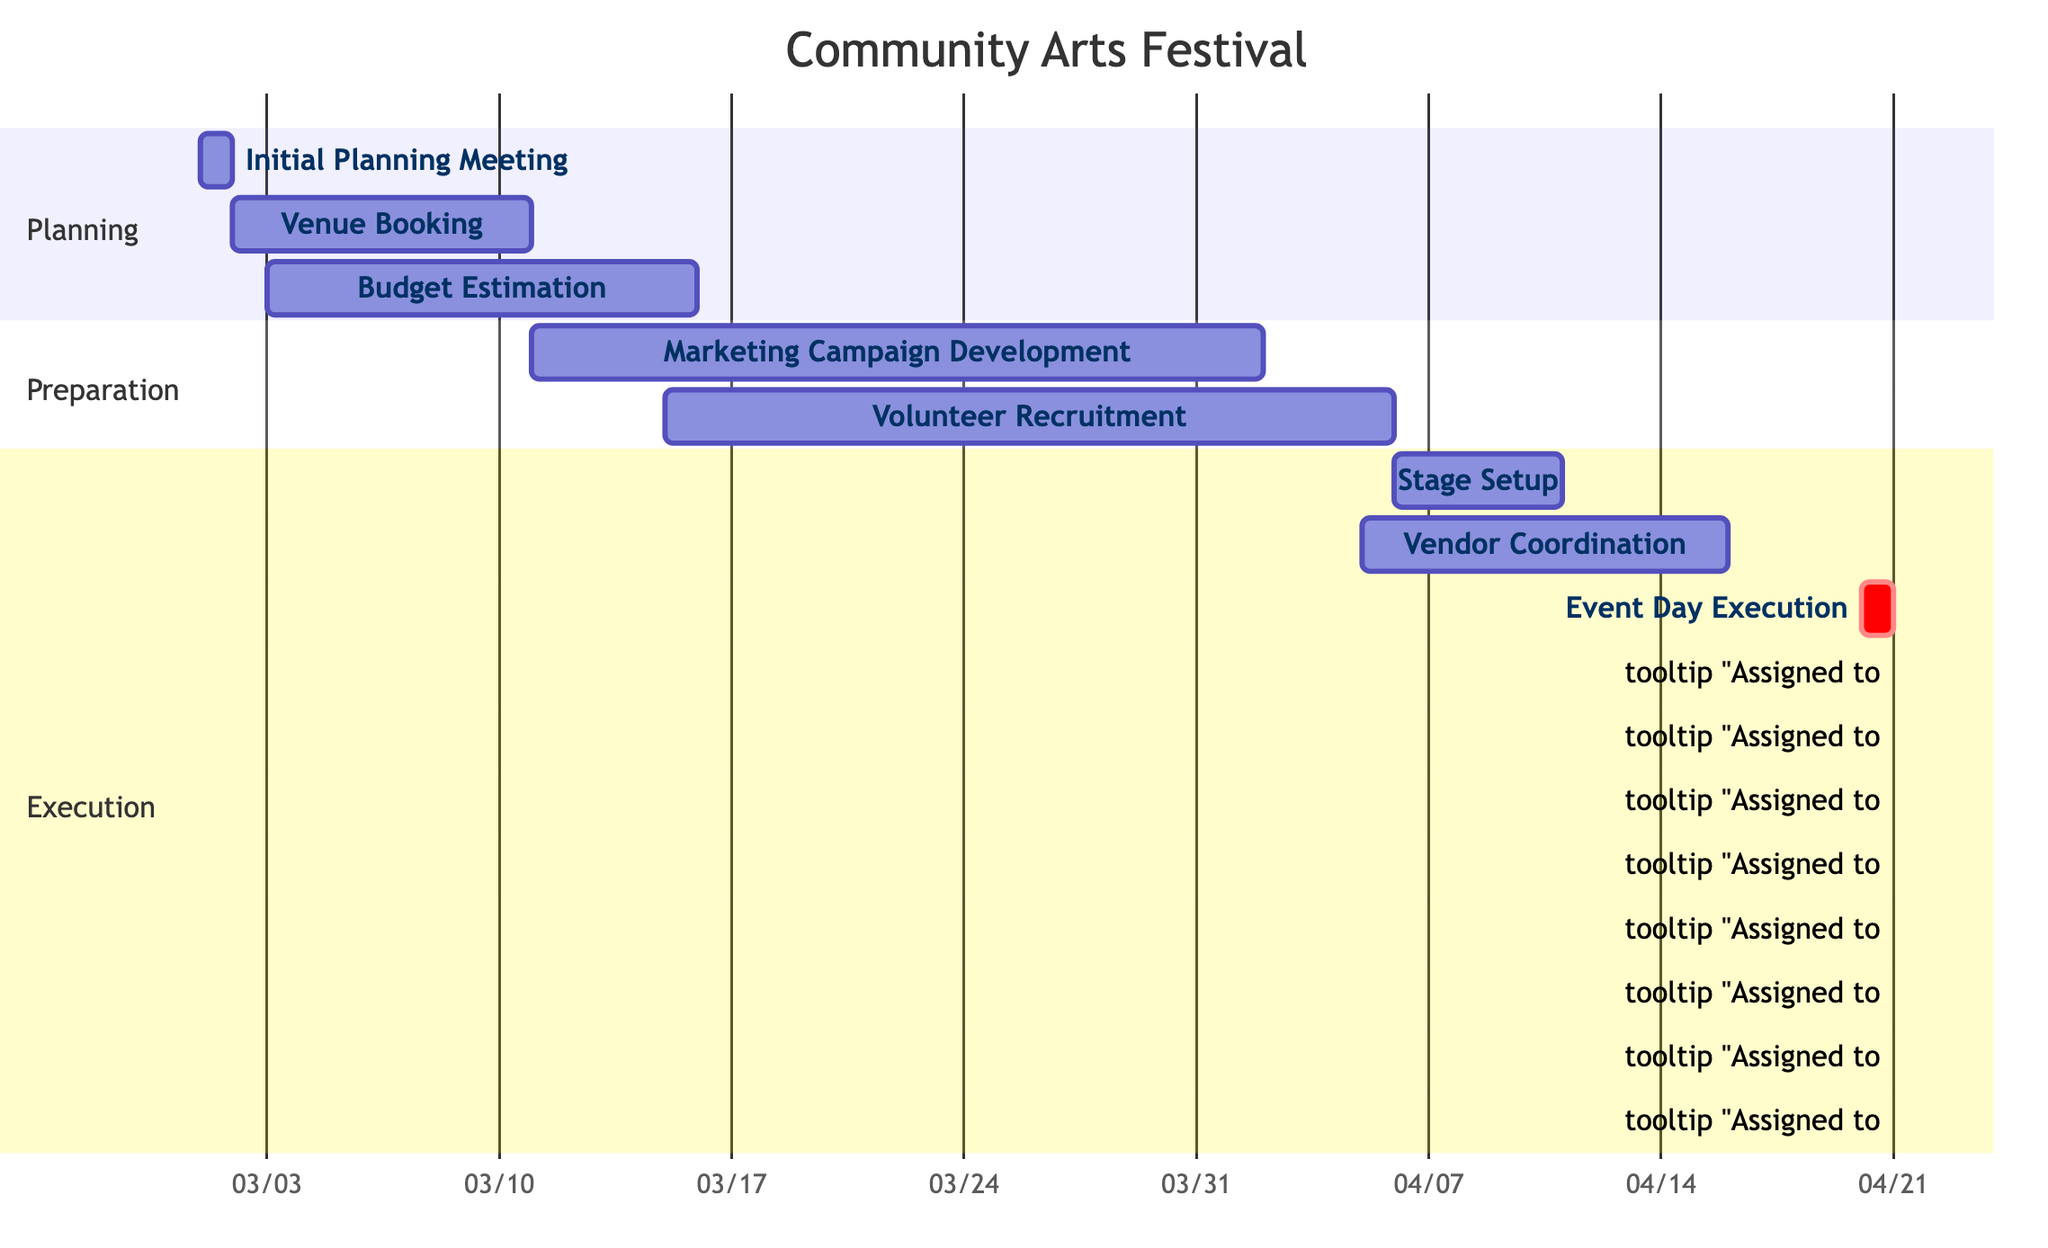What is the total number of tasks in the project? The project consists of eight tasks, which are listed under different sections in the Gantt Chart: Planning, Preparation, and Execution.
Answer: 8 Who is responsible for the Event Day Execution task? The Event Day Execution task is assigned to "All Team Members" as indicated in the diagram.
Answer: All Team Members What is the duration of the Venue Booking task? The Venue Booking task starts on March 2, 2024, and ends on March 10, 2024, giving it a duration of nine days.
Answer: 9 days Which task overlaps with the Budget Estimation task? Both the Venue Booking and Marketing Campaign Development tasks overlap with the Budget Estimation task, as they share a time frame.
Answer: Venue Booking and Marketing Campaign Development What is the earliest start date of any task in the project? The earliest start date is for the Initial Planning Meeting, which begins on March 1, 2024.
Answer: March 1, 2024 How many days does the Marketing Campaign Development task take? The Marketing Campaign Development task takes 22 days, starting from March 11, 2024, to April 1, 2024.
Answer: 22 days What is the final task in the sequence before the Event Day Execution? The Vendor Coordination task is the final task before the Event Day Execution, as it ends on April 15, 2024, a few days before the event.
Answer: Vendor Coordination Which tasks are handled by Alo Toom? Alo Toom is responsible for the Initial Planning Meeting and Vendor Coordination tasks, produced by examining their assigned responsibilities in the chart.
Answer: Initial Planning Meeting and Vendor Coordination 